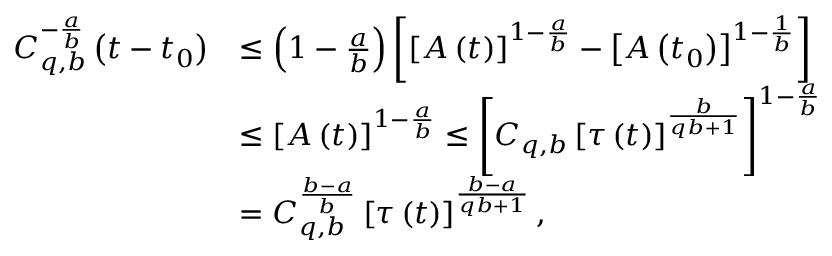<formula> <loc_0><loc_0><loc_500><loc_500>\begin{array} { r l } { C _ { q , b } ^ { - \frac { a } { b } } \left ( t - t _ { 0 } \right ) } & { \leq \left ( 1 - \frac { a } { b } \right ) \left [ \left [ A \left ( t \right ) \right ] ^ { 1 - \frac { a } { b } } - \left [ A \left ( t _ { 0 } \right ) \right ] ^ { 1 - \frac { 1 } { b } } \right ] } \\ & { \leq \left [ A \left ( t \right ) \right ] ^ { 1 - \frac { a } { b } } \leq \left [ C _ { q , b } \left [ \tau \left ( t \right ) \right ] ^ { \frac { b } { q b + 1 } } \right ] ^ { 1 - \frac { a } { b } } } \\ & { = C _ { q , b } ^ { \frac { b - a } { b } } \left [ \tau \left ( t \right ) \right ] ^ { \frac { b - a } { q b + 1 } } , } \end{array}</formula> 